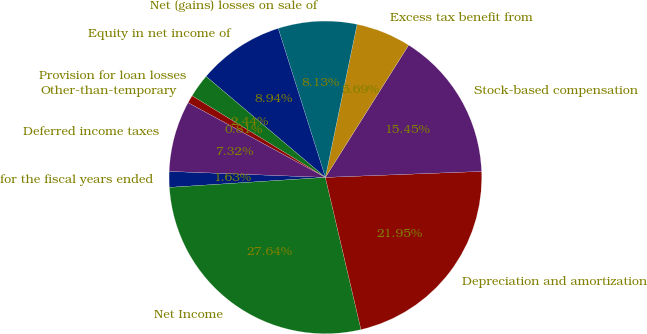Convert chart. <chart><loc_0><loc_0><loc_500><loc_500><pie_chart><fcel>for the fiscal years ended<fcel>Net Income<fcel>Depreciation and amortization<fcel>Stock-based compensation<fcel>Excess tax benefit from<fcel>Net (gains) losses on sale of<fcel>Equity in net income of<fcel>Provision for loan losses<fcel>Other-than-temporary<fcel>Deferred income taxes<nl><fcel>1.63%<fcel>27.64%<fcel>21.95%<fcel>15.45%<fcel>5.69%<fcel>8.13%<fcel>8.94%<fcel>2.44%<fcel>0.81%<fcel>7.32%<nl></chart> 